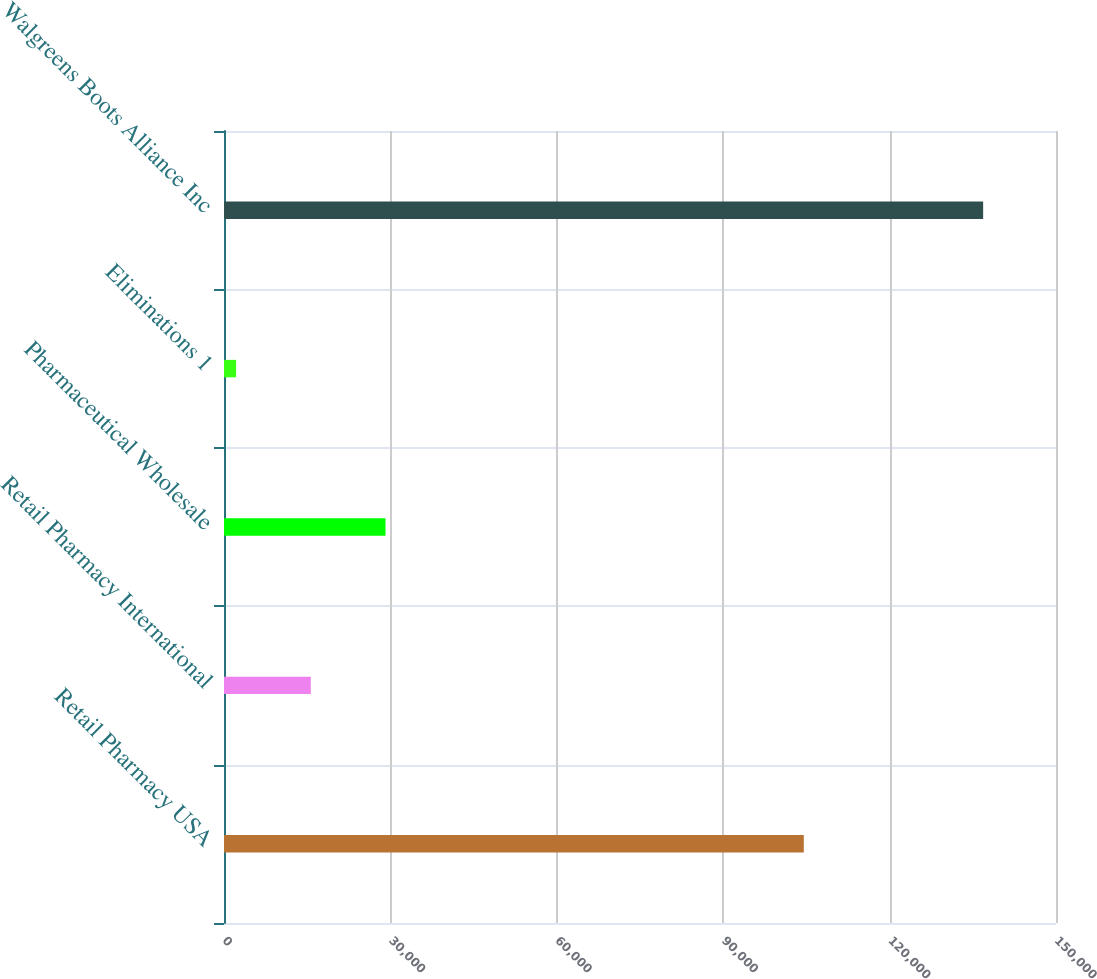<chart> <loc_0><loc_0><loc_500><loc_500><bar_chart><fcel>Retail Pharmacy USA<fcel>Retail Pharmacy International<fcel>Pharmaceutical Wholesale<fcel>Eliminations 1<fcel>Walgreens Boots Alliance Inc<nl><fcel>104532<fcel>15648.6<fcel>29117.2<fcel>2180<fcel>136866<nl></chart> 